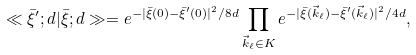<formula> <loc_0><loc_0><loc_500><loc_500>\ll \bar { \xi } ^ { \prime } ; d | \bar { \xi } ; d \gg = e ^ { - | \bar { \xi } ( 0 ) - \bar { \xi } ^ { \prime } ( 0 ) | ^ { 2 } / 8 d } \prod _ { \vec { k } _ { \ell } \in K } e ^ { - | \bar { \xi } ( \vec { k } _ { \ell } ) - \bar { \xi } ^ { \prime } ( \vec { k } _ { \ell } ) | ^ { 2 } / 4 d } ,</formula> 